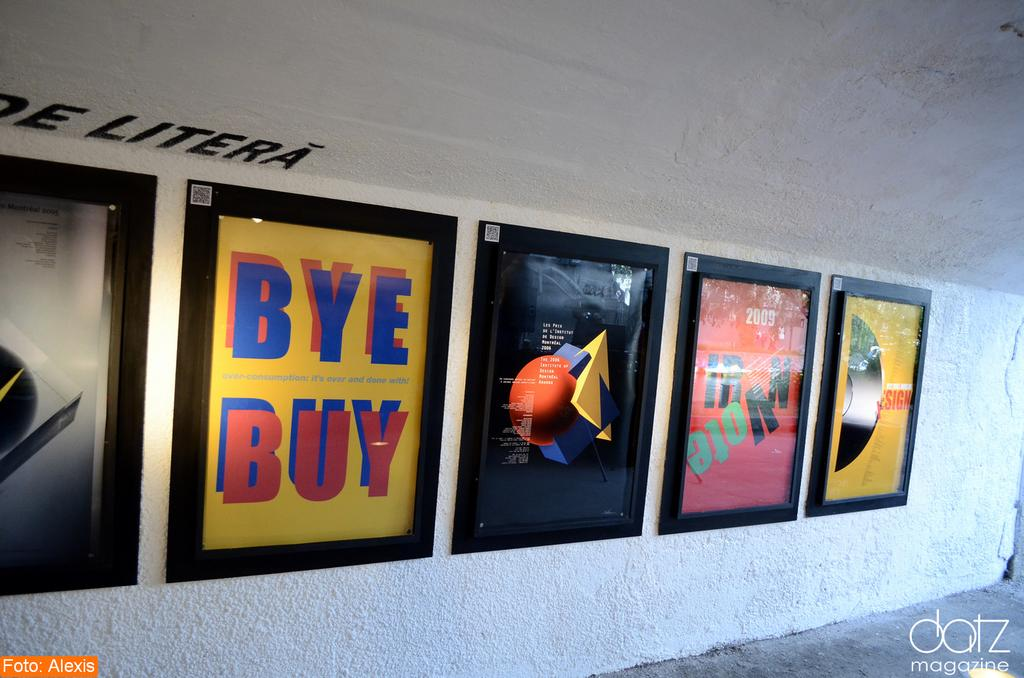<image>
Write a terse but informative summary of the picture. Several posters including a yellow one that says "Buy Bye" are framed on a white wall. 